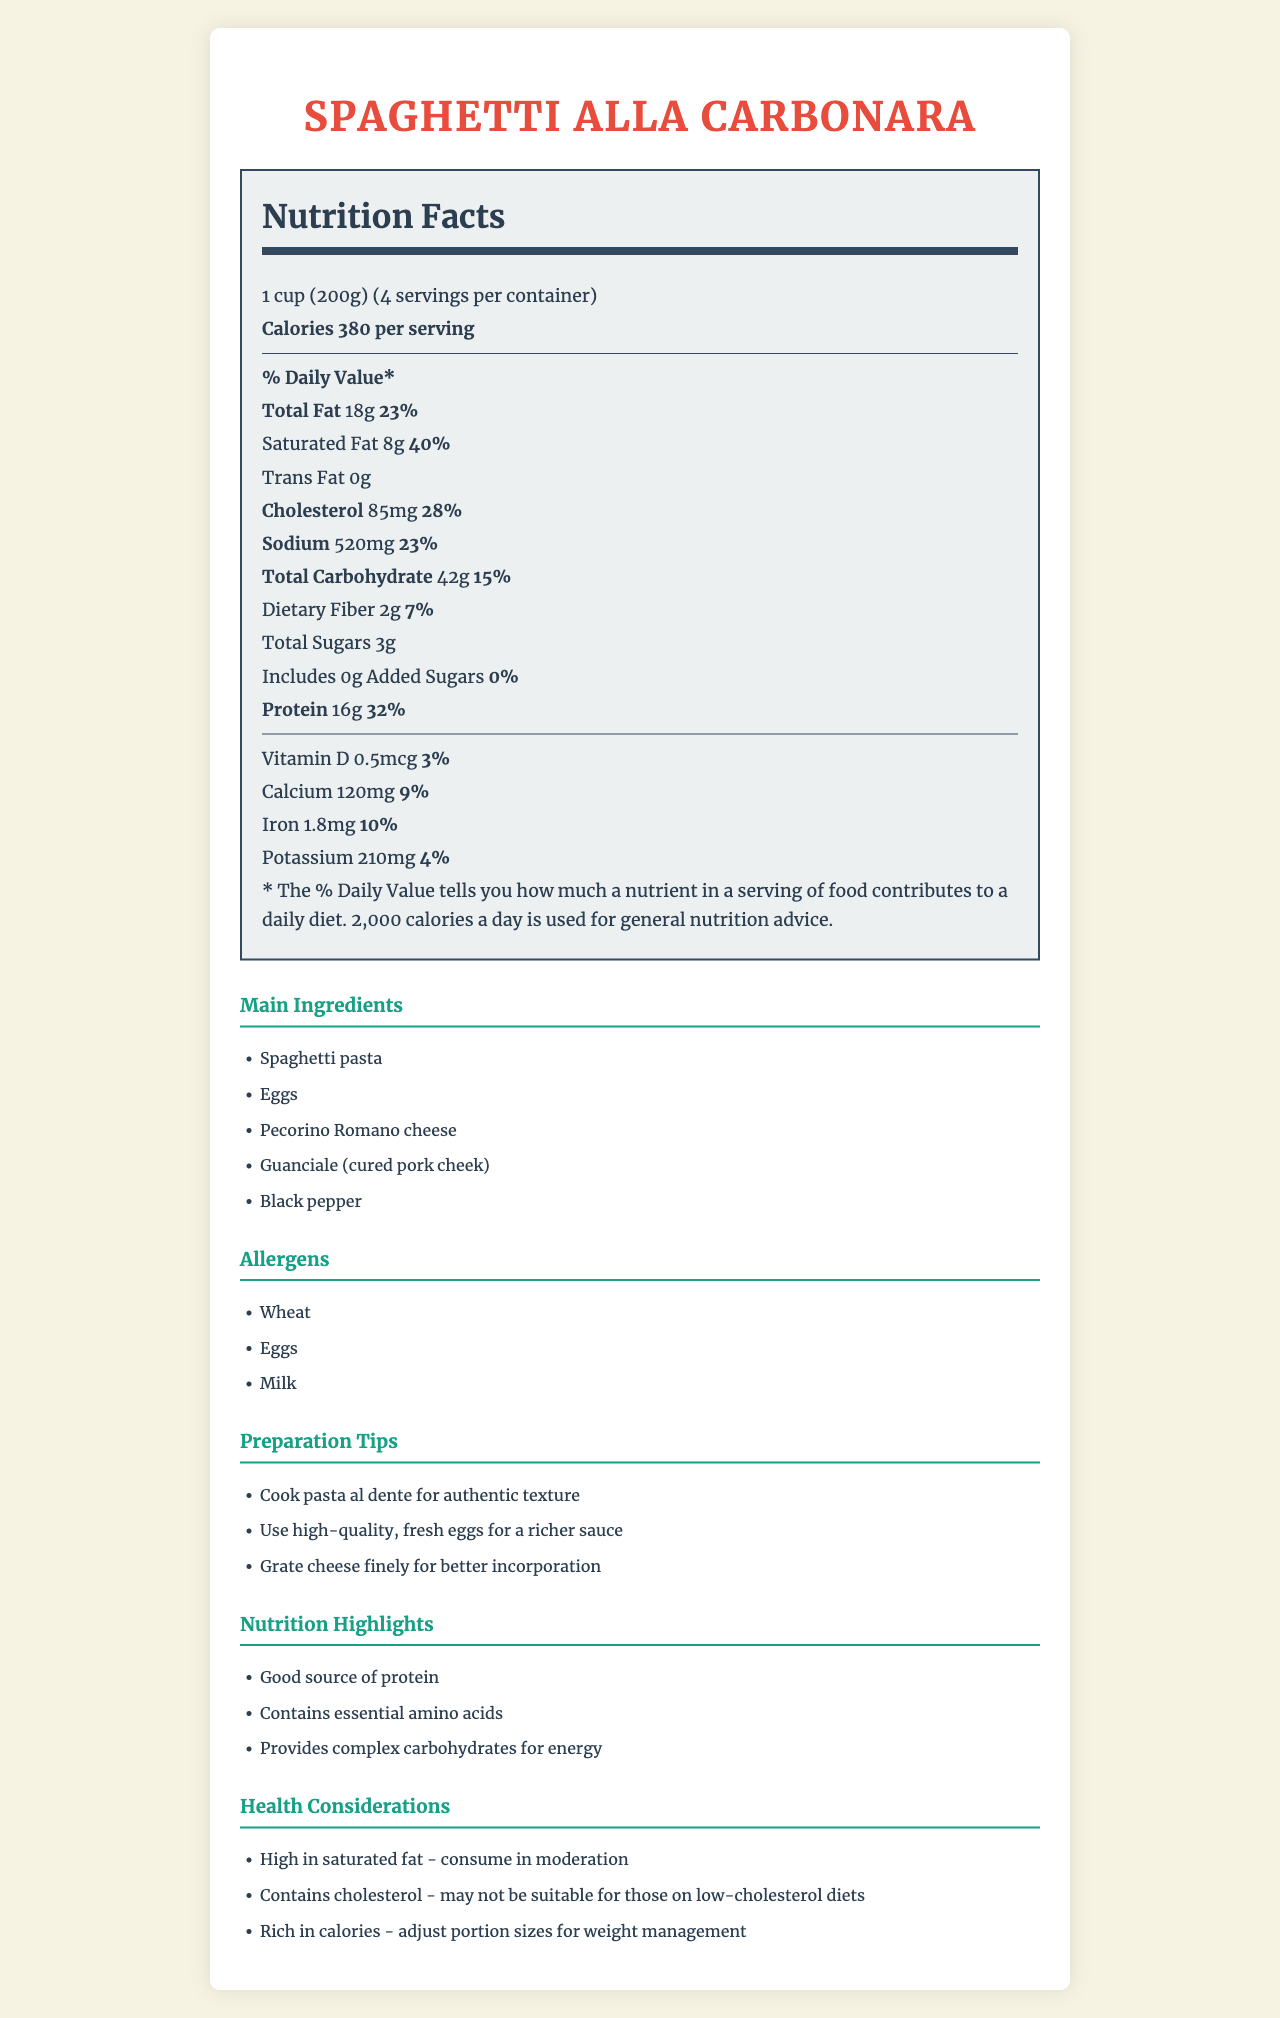what is the serving size of Spaghetti alla Carbonara? The serving size is stated as "1 cup (200g)" at the top of the nutrition label.
Answer: 1 cup (200g) how many servings are there per container? The document mentions "4 servings per container" right below the serving size.
Answer: 4 what is the total fat content per serving? The total fat content per serving is listed as "Total Fat 18g" under the % Daily Value section.
Answer: 18g how much protein is in one serving? The protein content is stated as "Protein 16g" in the document.
Answer: 16g what are the main allergens present in the dish? The allergens section of the document lists "Wheat", "Eggs", and "Milk".
Answer: Wheat, Eggs, Milk how much sodium does one serving contain? The document specifies that one serving contains 520mg of sodium.
Answer: 520mg What percentage of the daily value of saturated fat does one serving provide? According to the nutrition label, one serving contributes 40% to the daily value of saturated fat.
Answer: 40% which of these ingredients is not a main ingredient in Spaghetti alla Carbonara? A. Spaghetti pasta B. Eggs C. Tomato sauce D. Pecorino Romano cheese The main ingredients listed are "Spaghetti pasta", "Eggs", "Pecorino Romano cheese", "Guanciale (cured pork cheek)", and "Black pepper". Tomato sauce is not mentioned.
Answer: C. Tomato sauce How many grams of dietary fiber are there in each serving? A. 1g B. 2g C. 3g D. 5g The document mentions "Dietary Fiber 2g" in the nutrition label.
Answer: B. 2g Should someone on a low-cholesterol diet consume this dish frequently? The document indicates that the dish contains 85mg of cholesterol and also notes that it "may not be suitable for those on low-cholesterol diets".
Answer: No Summarize the main nutritional characteristics of Spaghetti alla Carbonara. The nutrition label provides detailed macronutrient information, including calories, and percentages of the daily value for various contents like fat, sodium, and protein. Main ingredients and allergens are also listed along with health considerations and preparation tips.
Answer: Spaghetti alla Carbonara is a rich Italian pasta dish containing high protein and carbohydrates with notable amounts of cholesterol and saturated fat. It is high in calories and should be consumed in moderation. The main ingredients include spaghetti pasta, eggs, Pecorino Romano cheese, Guanciale, and black pepper. Key highlights include its protein content and essential amino acids, while considerations include its high saturated fat and cholesterol content. what is the process of making the sauce richer as suggested in the preparation tips? One of the preparation tips in the document advises using high-quality, fresh eggs for a richer sauce.
Answer: Use high-quality, fresh eggs are there any added sugars in Spaghetti alla Carbonara? The document states that there are 0g of added sugars in the dish.
Answer: No how much calcium does each serving provide in terms of the daily value? The nutrition label shows that one serving provides 9% of the daily value for calcium.
Answer: 9% how should the cheese be prepared for better incorporation according to the document? The preparation tips section recommends grating cheese finely for better incorporation.
Answer: Grate cheese finely What vitamin content is listed in the nutrition label? The document lists "Vitamin D 0.5mcg" with a daily value contribution of 3%.
Answer: Vitamin D How much potassium is in one serving of Spaghetti alla Carbonara? The nutrition label indicates that each serving contains 210mg of potassium.
Answer: 210mg What are the three nutrition highlights mentioned in the document? The nutrition highlights section lists these three points.
Answer: Good source of protein; Contains essential amino acids; Provides complex carbohydrates for energy What specific type of pasta is used in Spaghetti alla Carbonara? The document mentions "Spaghetti pasta", but does not specify a particular type of spaghetti (e.g., whole wheat, gluten-free).
Answer: Cannot be determined 